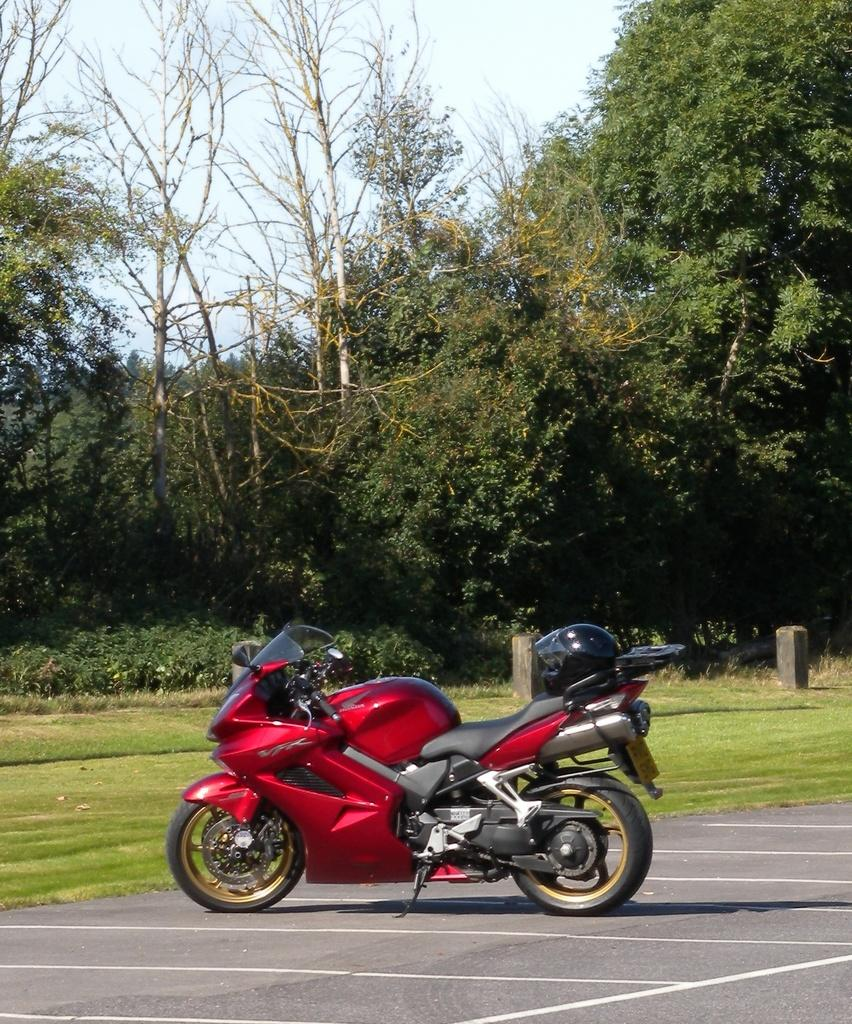What type of vehicle is in the image? There is a motorbike in the image. What is the status of the motorbike in the image? The motorbike is parked. What safety accessory is placed on the motorbike? There is a helmet placed on the motorbike. What type of vegetation is visible in the image? There is grass visible in the image. What type of trees are present in the image? There are trees with branches and leaves in the image. What part of the natural environment is visible in the image? The sky is visible in the image. What type of rice is being cooked in the image? There is no rice present in the image; it features a parked motorbike with a helmet and a natural environment. How many hands are visible in the image? There are no hands visible in the image. 